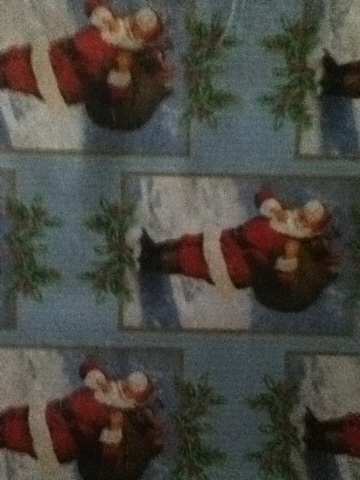How would you describe the colors and design elements found on this wrapping paper? The wrapping paper predominantly features Christmas-themed colors like red, white, and a touch of green from the mistletoe. The design elements include images of Santa Claus carrying a bag of gifts, repeated against a wintery background likely representing a snowy landscape. The use of traditional holiday symbols and colors makes the design instantly recognizable as Christmas-themed. 